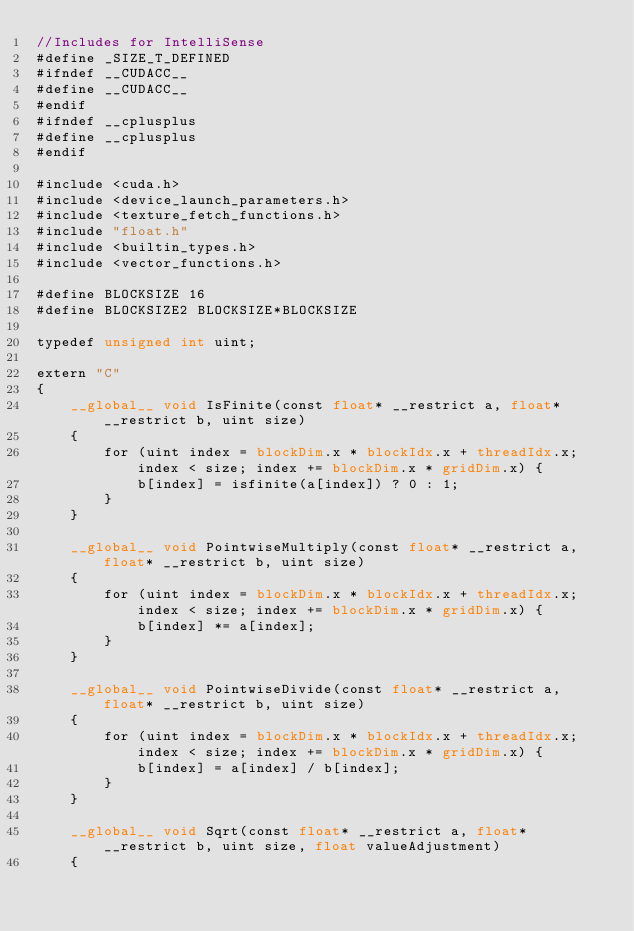Convert code to text. <code><loc_0><loc_0><loc_500><loc_500><_Cuda_>//Includes for IntelliSense 
#define _SIZE_T_DEFINED
#ifndef __CUDACC__
#define __CUDACC__
#endif
#ifndef __cplusplus
#define __cplusplus
#endif

#include <cuda.h>
#include <device_launch_parameters.h>
#include <texture_fetch_functions.h>
#include "float.h"
#include <builtin_types.h>
#include <vector_functions.h>

#define BLOCKSIZE 16
#define BLOCKSIZE2 BLOCKSIZE*BLOCKSIZE

typedef unsigned int uint;

extern "C"
{
    __global__ void IsFinite(const float* __restrict a, float* __restrict b, uint size)
	{
        for (uint index = blockDim.x * blockIdx.x + threadIdx.x; index < size; index += blockDim.x * gridDim.x) {
            b[index] = isfinite(a[index]) ? 0 : 1;
        }
	}

	__global__ void PointwiseMultiply(const float* __restrict a, float* __restrict b, uint size)
	{
        for (uint index = blockDim.x * blockIdx.x + threadIdx.x; index < size; index += blockDim.x * gridDim.x) {
            b[index] *= a[index];
        }
	}

	__global__ void PointwiseDivide(const float* __restrict a, float* __restrict b, uint size)
	{
        for (uint index = blockDim.x * blockIdx.x + threadIdx.x; index < size; index += blockDim.x * gridDim.x) {
            b[index] = a[index] / b[index];
        }
	}

	__global__ void Sqrt(const float* __restrict a, float* __restrict b, uint size, float valueAdjustment)
	{</code> 